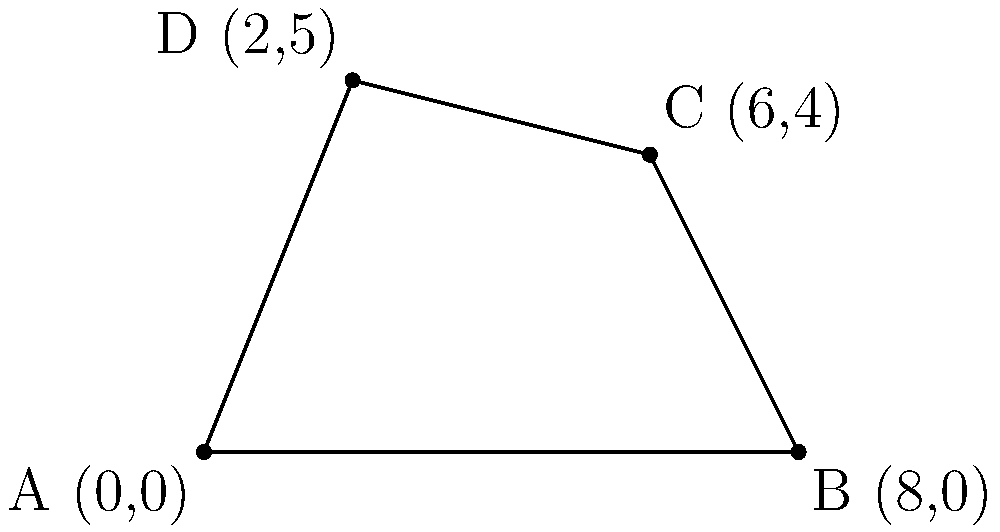During an excavation in Scotland, you've uncovered an irregularly shaped site that might contain evidence of mythological creatures. The site's boundaries are marked by four points: A(0,0), B(8,0), C(6,4), and D(2,5). Using coordinate geometry and triangulation, calculate the total area of this excavation site in square meters. To find the area of this irregular quadrilateral, we can divide it into two triangles and calculate their areas separately:

1. Triangle ABD:
   Area = $\frac{1}{2}|x_1(y_2 - y_3) + x_2(y_3 - y_1) + x_3(y_1 - y_2)|$
   where $(x_1,y_1) = (0,0)$, $(x_2,y_2) = (8,0)$, and $(x_3,y_3) = (2,5)$
   
   Area_ABD = $\frac{1}{2}|0(0 - 5) + 8(5 - 0) + 2(0 - 0)|$
             = $\frac{1}{2}|0 + 40 + 0|$ = 20 sq meters

2. Triangle BCD:
   Area = $\frac{1}{2}|x_1(y_2 - y_3) + x_2(y_3 - y_1) + x_3(y_1 - y_2)|$
   where $(x_1,y_1) = (8,0)$, $(x_2,y_2) = (6,4)$, and $(x_3,y_3) = (2,5)$
   
   Area_BCD = $\frac{1}{2}|8(4 - 5) + 6(5 - 0) + 2(0 - 4)|$
             = $\frac{1}{2}|-8 + 30 - 8|$ = 7 sq meters

3. Total Area = Area_ABD + Area_BCD
              = 20 + 7 = 27 sq meters
Answer: 27 sq meters 